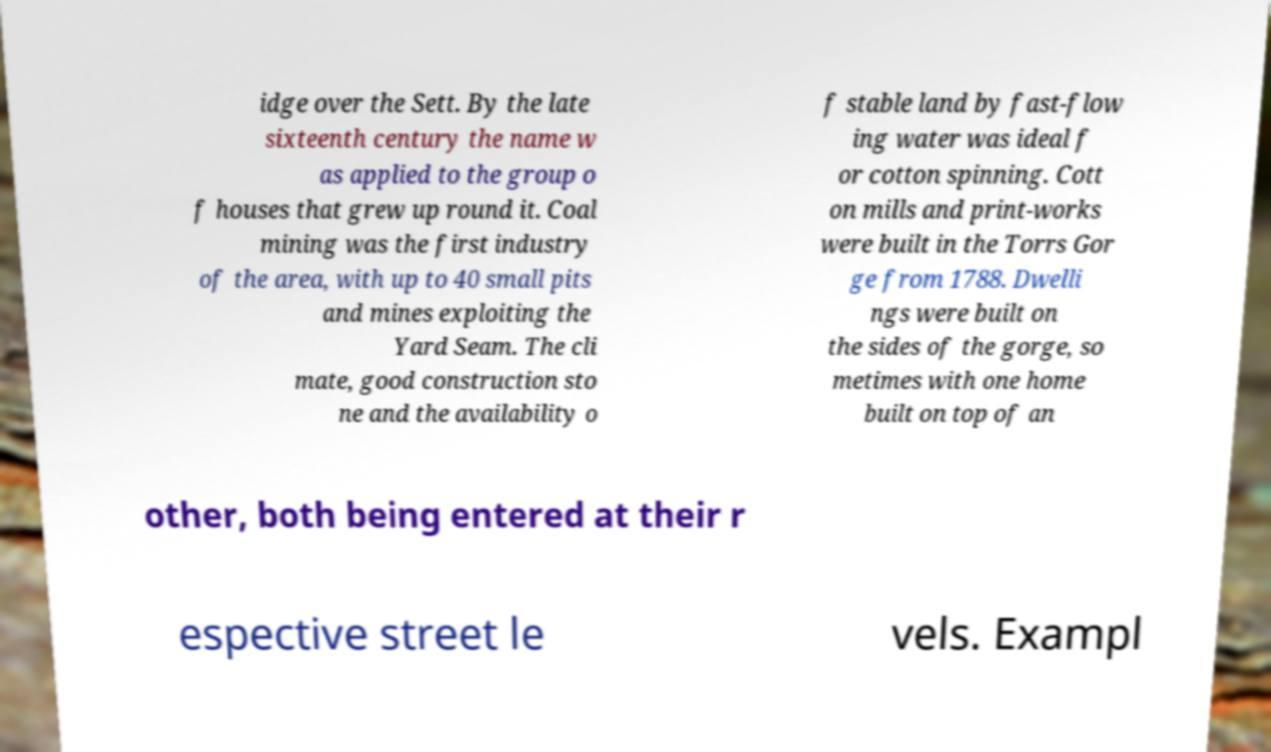For documentation purposes, I need the text within this image transcribed. Could you provide that? idge over the Sett. By the late sixteenth century the name w as applied to the group o f houses that grew up round it. Coal mining was the first industry of the area, with up to 40 small pits and mines exploiting the Yard Seam. The cli mate, good construction sto ne and the availability o f stable land by fast-flow ing water was ideal f or cotton spinning. Cott on mills and print-works were built in the Torrs Gor ge from 1788. Dwelli ngs were built on the sides of the gorge, so metimes with one home built on top of an other, both being entered at their r espective street le vels. Exampl 